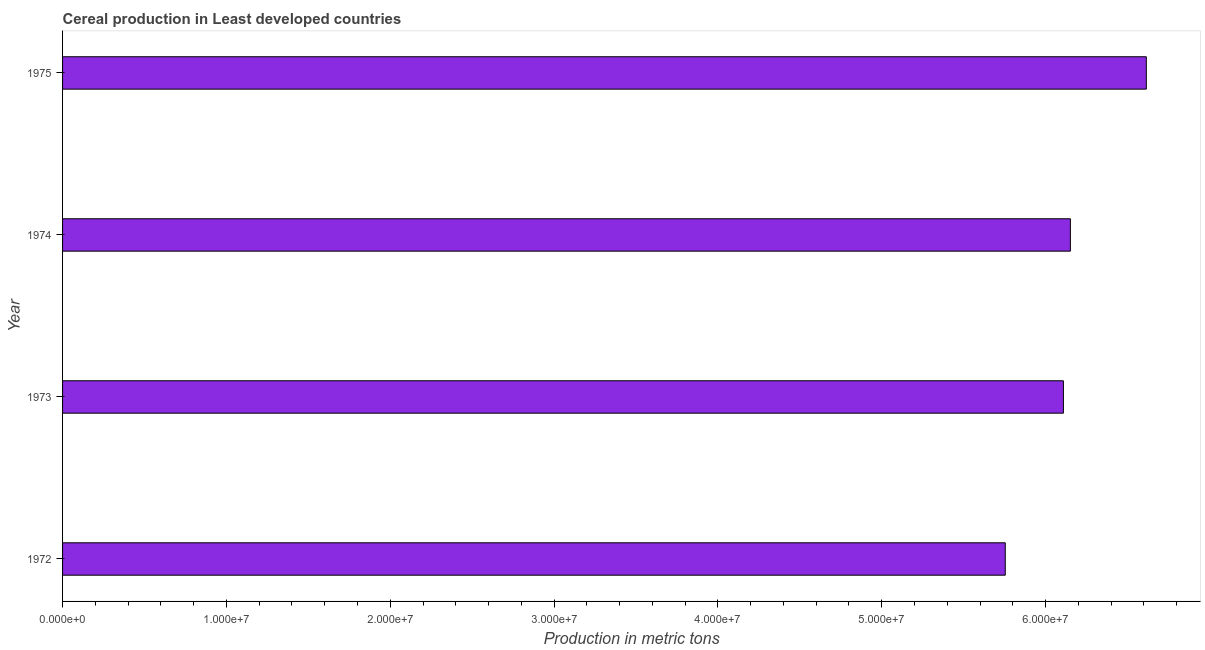What is the title of the graph?
Your answer should be very brief. Cereal production in Least developed countries. What is the label or title of the X-axis?
Ensure brevity in your answer.  Production in metric tons. What is the cereal production in 1973?
Your answer should be compact. 6.11e+07. Across all years, what is the maximum cereal production?
Give a very brief answer. 6.62e+07. Across all years, what is the minimum cereal production?
Give a very brief answer. 5.75e+07. In which year was the cereal production maximum?
Make the answer very short. 1975. In which year was the cereal production minimum?
Your response must be concise. 1972. What is the sum of the cereal production?
Offer a terse response. 2.46e+08. What is the difference between the cereal production in 1972 and 1973?
Your answer should be compact. -3.55e+06. What is the average cereal production per year?
Make the answer very short. 6.16e+07. What is the median cereal production?
Ensure brevity in your answer.  6.13e+07. In how many years, is the cereal production greater than 24000000 metric tons?
Offer a very short reply. 4. Do a majority of the years between 1973 and 1972 (inclusive) have cereal production greater than 56000000 metric tons?
Provide a succinct answer. No. What is the ratio of the cereal production in 1972 to that in 1973?
Ensure brevity in your answer.  0.94. Is the cereal production in 1972 less than that in 1975?
Make the answer very short. Yes. What is the difference between the highest and the second highest cereal production?
Make the answer very short. 4.63e+06. Is the sum of the cereal production in 1974 and 1975 greater than the maximum cereal production across all years?
Your answer should be very brief. Yes. What is the difference between the highest and the lowest cereal production?
Offer a very short reply. 8.61e+06. How many years are there in the graph?
Offer a very short reply. 4. What is the difference between two consecutive major ticks on the X-axis?
Keep it short and to the point. 1.00e+07. What is the Production in metric tons of 1972?
Ensure brevity in your answer.  5.75e+07. What is the Production in metric tons of 1973?
Make the answer very short. 6.11e+07. What is the Production in metric tons in 1974?
Keep it short and to the point. 6.15e+07. What is the Production in metric tons in 1975?
Make the answer very short. 6.62e+07. What is the difference between the Production in metric tons in 1972 and 1973?
Offer a very short reply. -3.55e+06. What is the difference between the Production in metric tons in 1972 and 1974?
Your response must be concise. -3.97e+06. What is the difference between the Production in metric tons in 1972 and 1975?
Keep it short and to the point. -8.61e+06. What is the difference between the Production in metric tons in 1973 and 1974?
Give a very brief answer. -4.25e+05. What is the difference between the Production in metric tons in 1973 and 1975?
Offer a very short reply. -5.06e+06. What is the difference between the Production in metric tons in 1974 and 1975?
Your response must be concise. -4.63e+06. What is the ratio of the Production in metric tons in 1972 to that in 1973?
Offer a very short reply. 0.94. What is the ratio of the Production in metric tons in 1972 to that in 1974?
Provide a succinct answer. 0.94. What is the ratio of the Production in metric tons in 1972 to that in 1975?
Offer a very short reply. 0.87. What is the ratio of the Production in metric tons in 1973 to that in 1975?
Ensure brevity in your answer.  0.92. What is the ratio of the Production in metric tons in 1974 to that in 1975?
Make the answer very short. 0.93. 